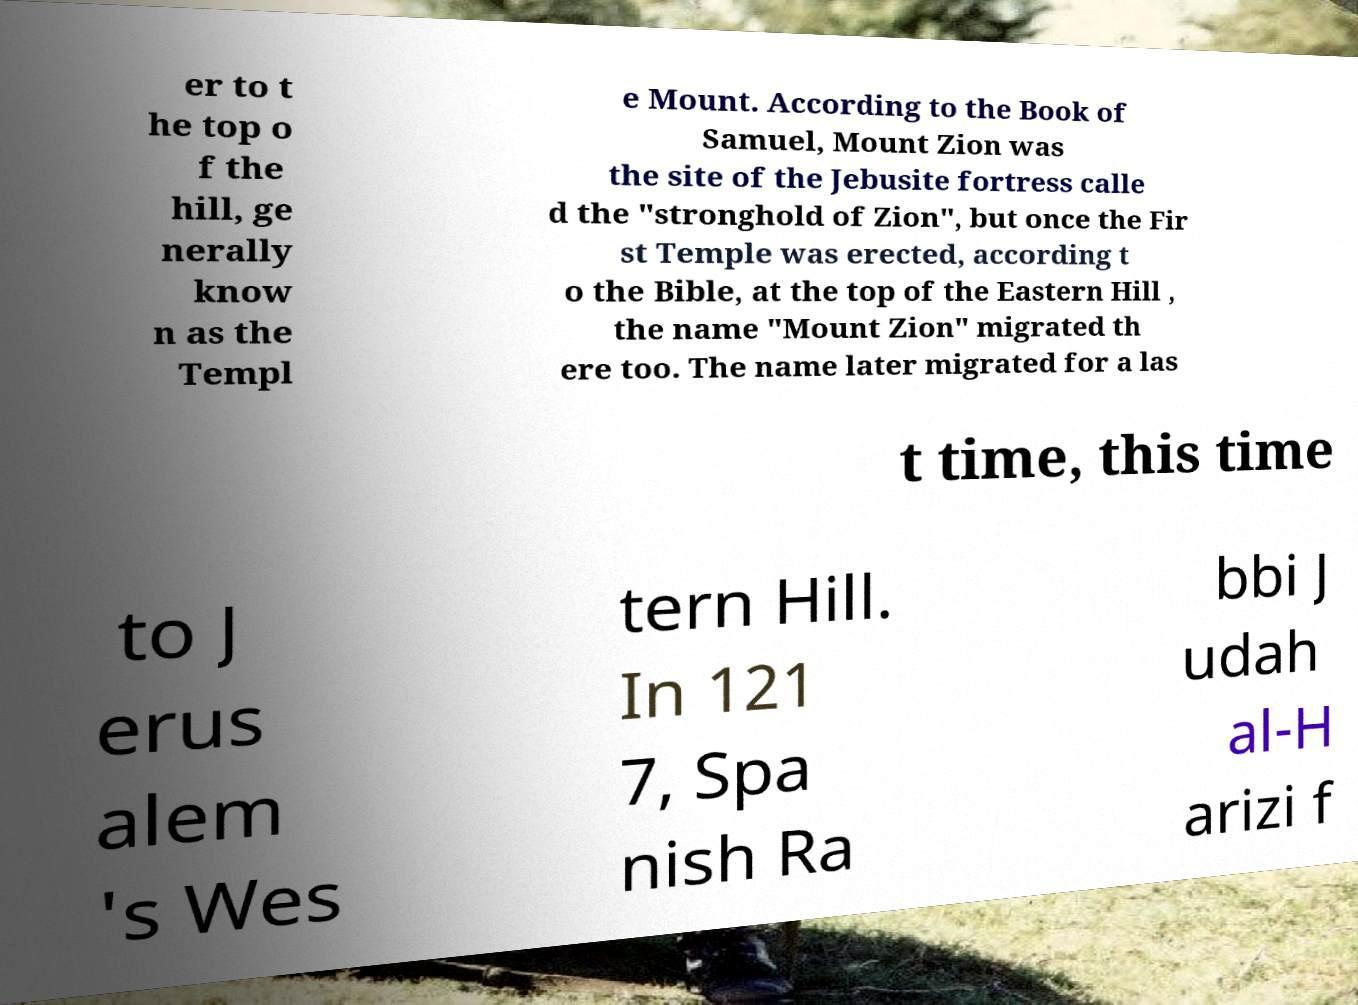Could you assist in decoding the text presented in this image and type it out clearly? er to t he top o f the hill, ge nerally know n as the Templ e Mount. According to the Book of Samuel, Mount Zion was the site of the Jebusite fortress calle d the "stronghold of Zion", but once the Fir st Temple was erected, according t o the Bible, at the top of the Eastern Hill , the name "Mount Zion" migrated th ere too. The name later migrated for a las t time, this time to J erus alem 's Wes tern Hill. In 121 7, Spa nish Ra bbi J udah al-H arizi f 